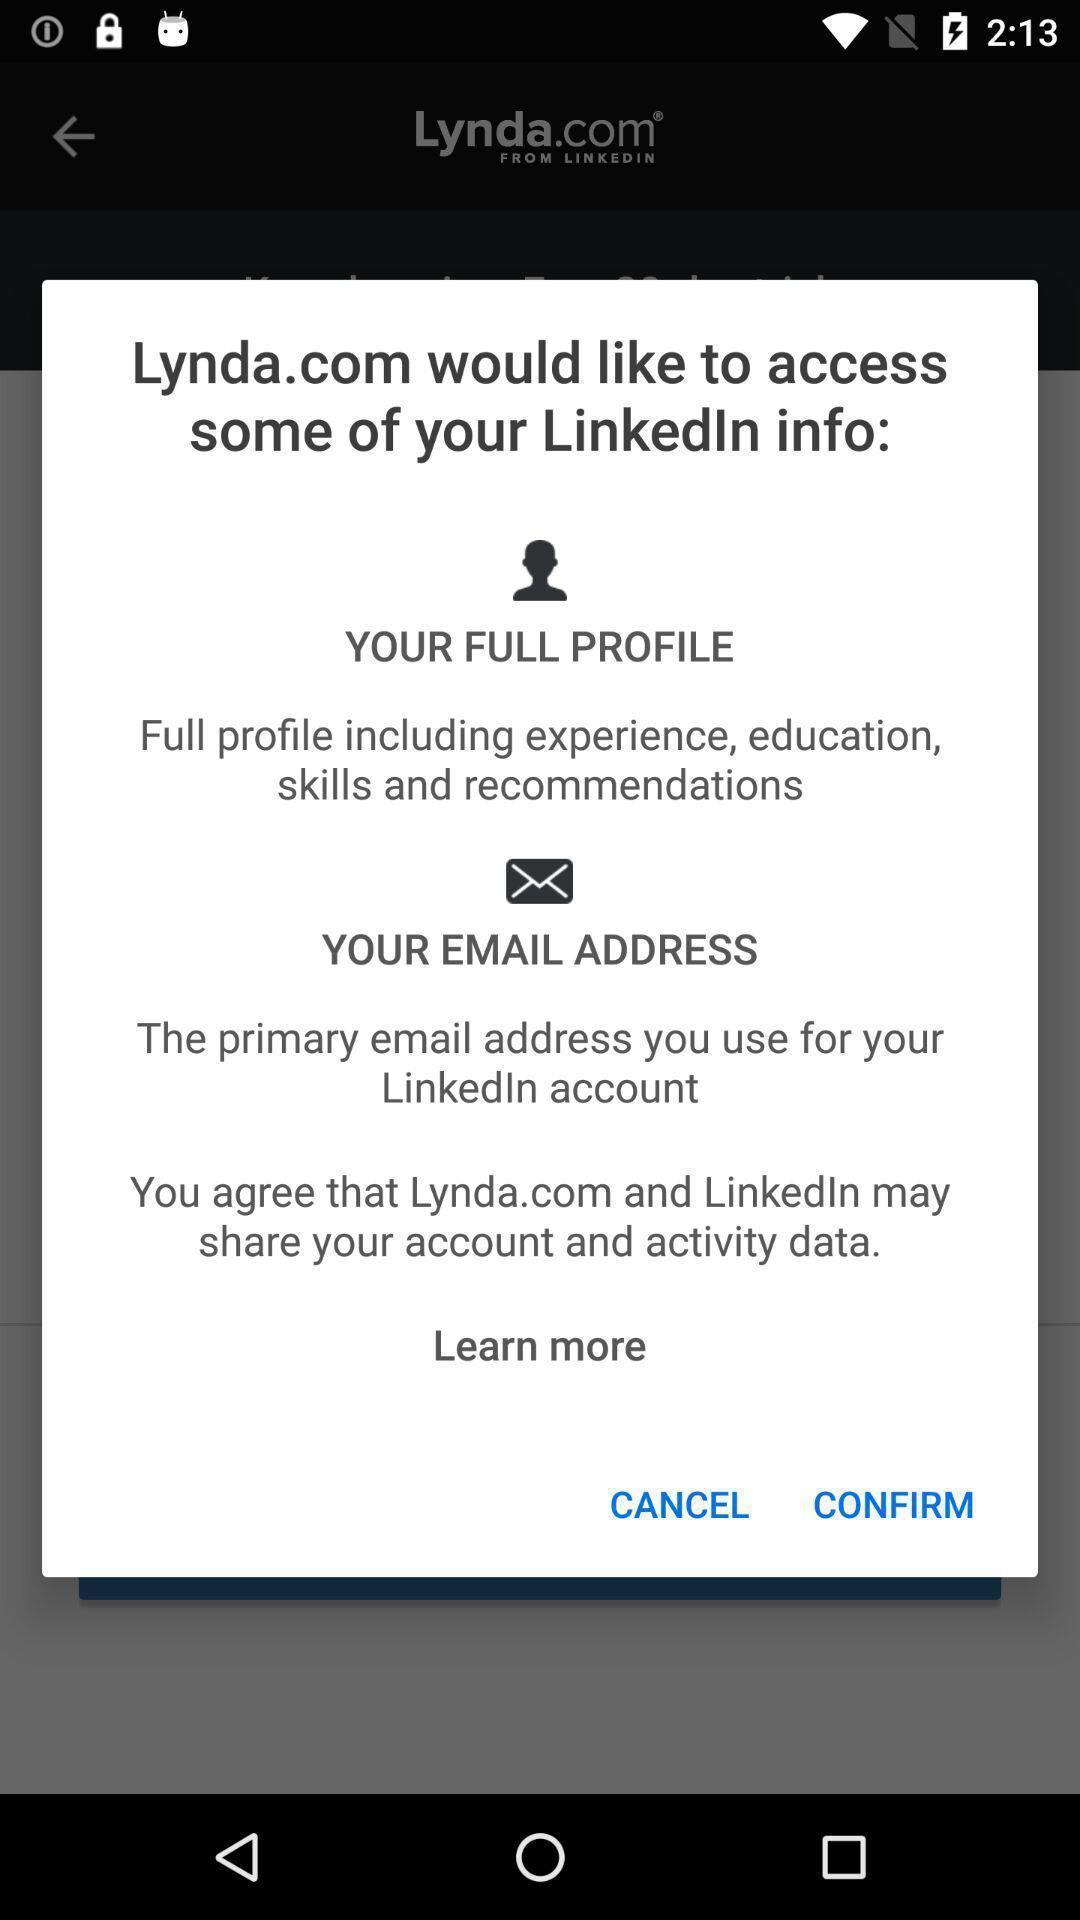What details can you identify in this image? Popup displaying permission to access an app. 